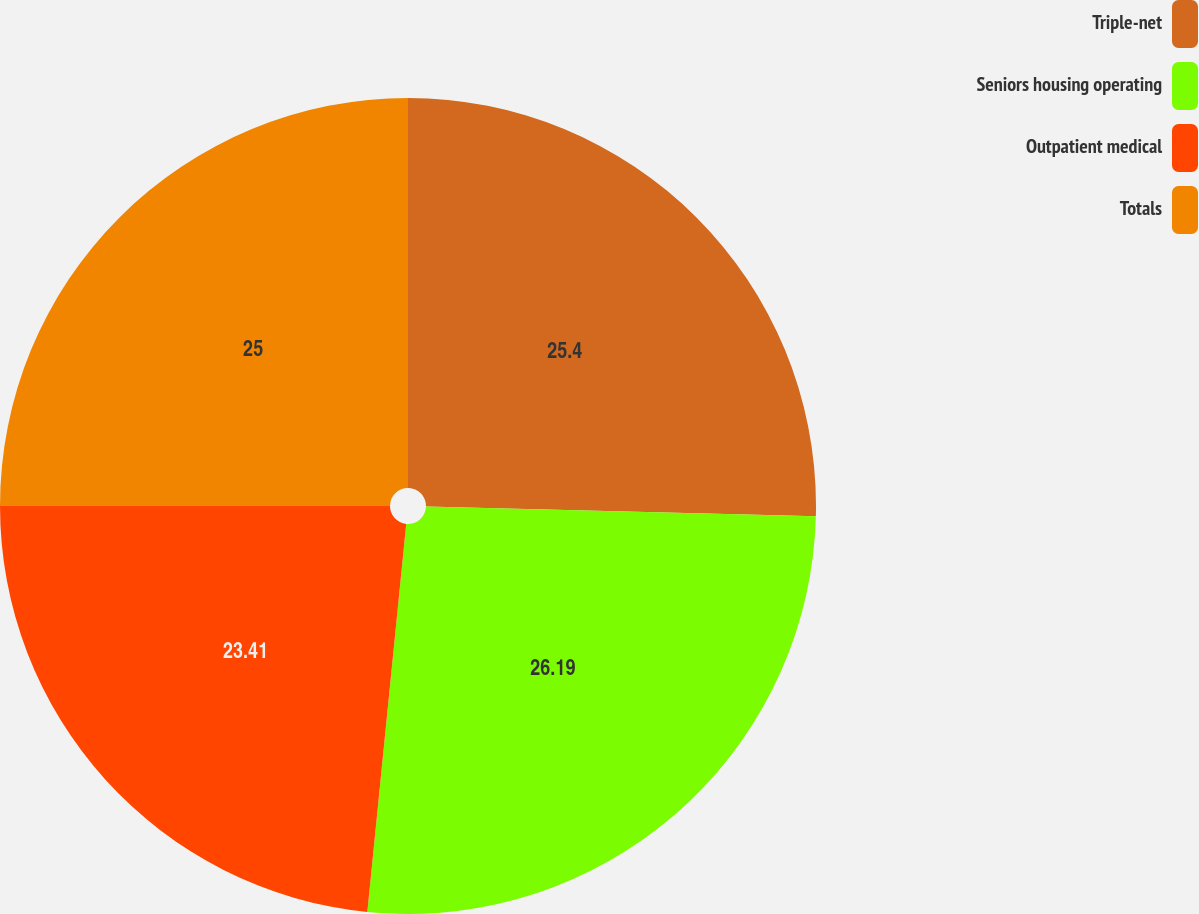Convert chart to OTSL. <chart><loc_0><loc_0><loc_500><loc_500><pie_chart><fcel>Triple-net<fcel>Seniors housing operating<fcel>Outpatient medical<fcel>Totals<nl><fcel>25.4%<fcel>26.19%<fcel>23.41%<fcel>25.0%<nl></chart> 